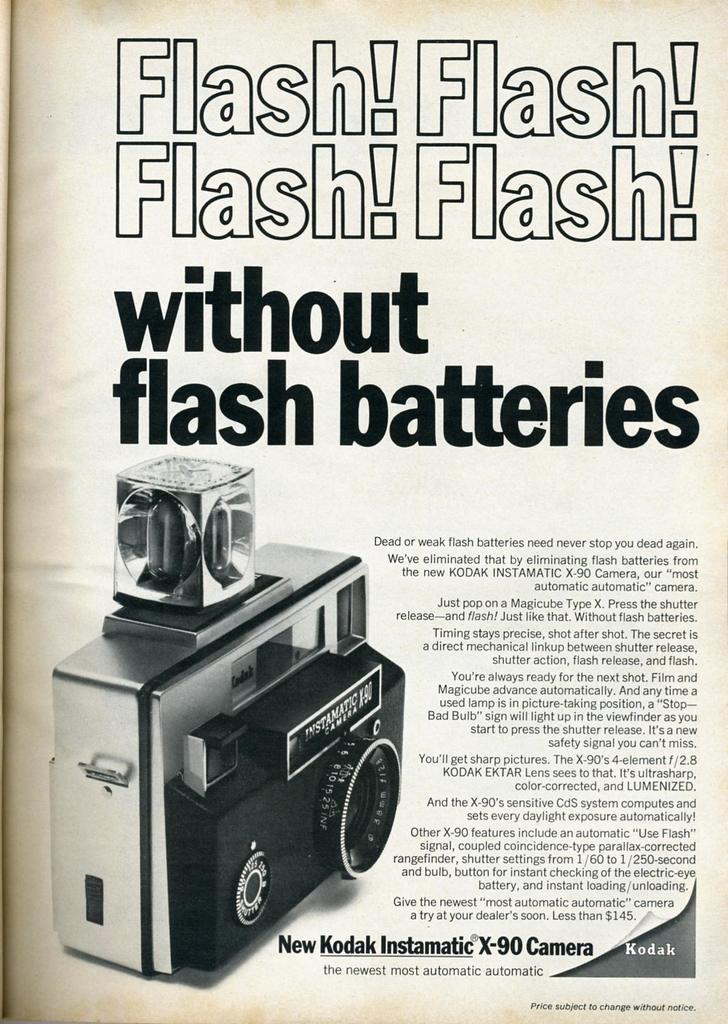Can you describe this image briefly? In this picture we can see a page, where we can see a camera and some text on it. 